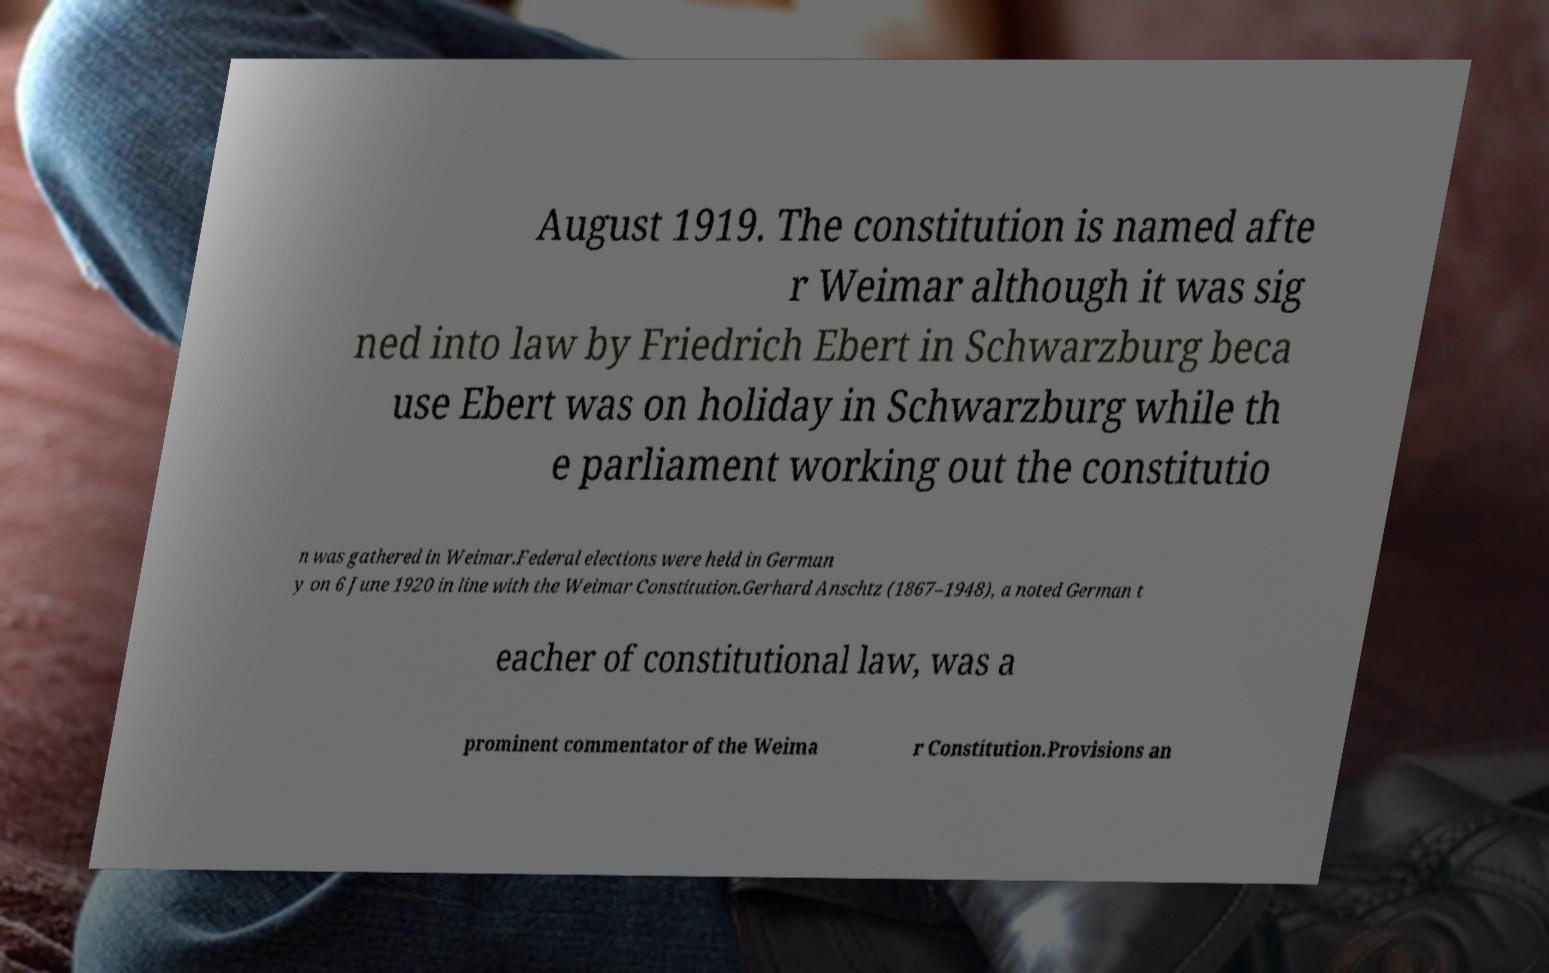There's text embedded in this image that I need extracted. Can you transcribe it verbatim? August 1919. The constitution is named afte r Weimar although it was sig ned into law by Friedrich Ebert in Schwarzburg beca use Ebert was on holiday in Schwarzburg while th e parliament working out the constitutio n was gathered in Weimar.Federal elections were held in German y on 6 June 1920 in line with the Weimar Constitution.Gerhard Anschtz (1867–1948), a noted German t eacher of constitutional law, was a prominent commentator of the Weima r Constitution.Provisions an 